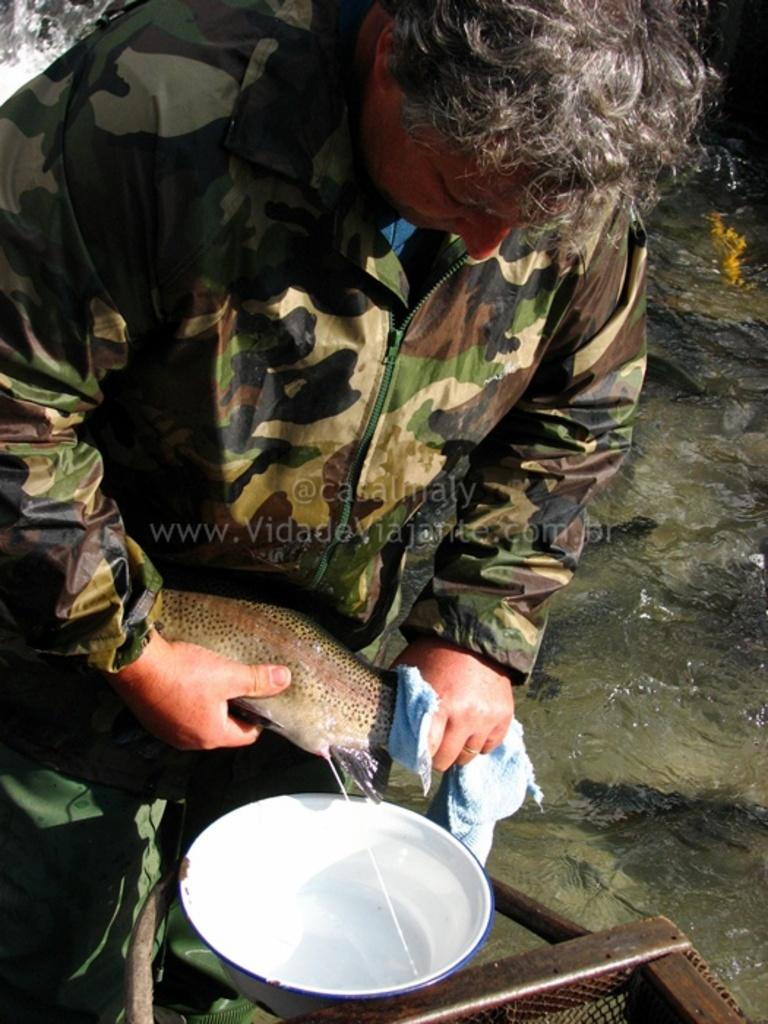What is the main subject of the image? There is a soldier in the image. What is the soldier doing in the image? The soldier is extracting liquid from a fish. How is the liquid being collected in the image? The liquid is being extracted into a bowl. What type of rake is being used by the soldier to extract the liquid from the fish? There is no rake present in the image; the soldier is using their hands to extract the liquid from the fish. 